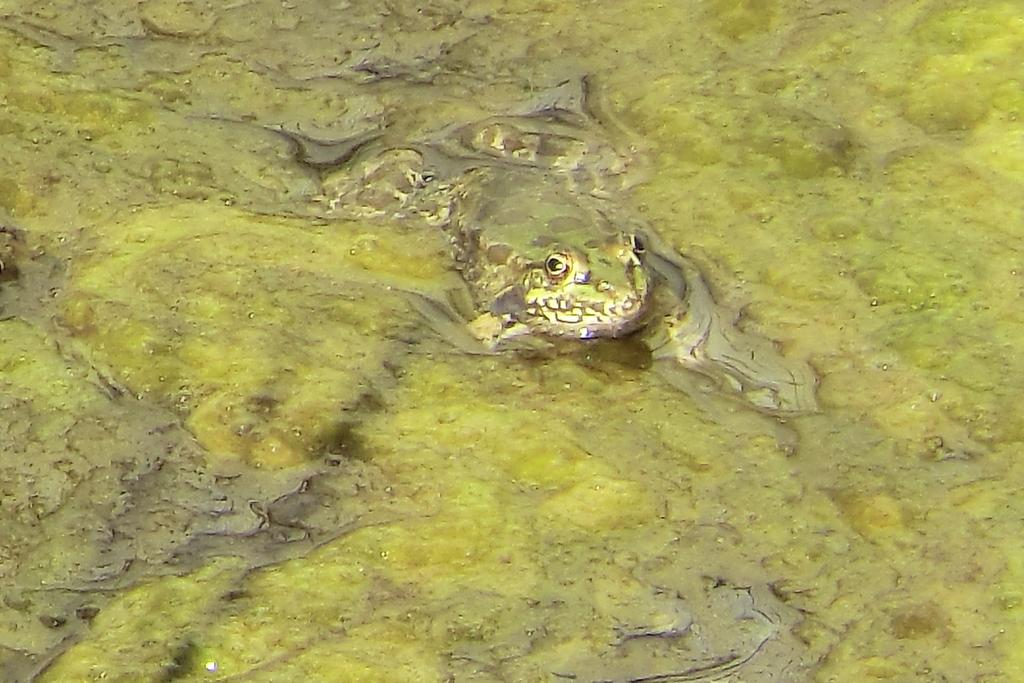What type of animal is in the image? There is a frog in the image. What is the frog's environment in the image? The frog is in algae water. What type of pipe can be seen in the image? There is no pipe present in the image; it features a frog in algae water. 